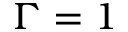<formula> <loc_0><loc_0><loc_500><loc_500>\Gamma = 1</formula> 